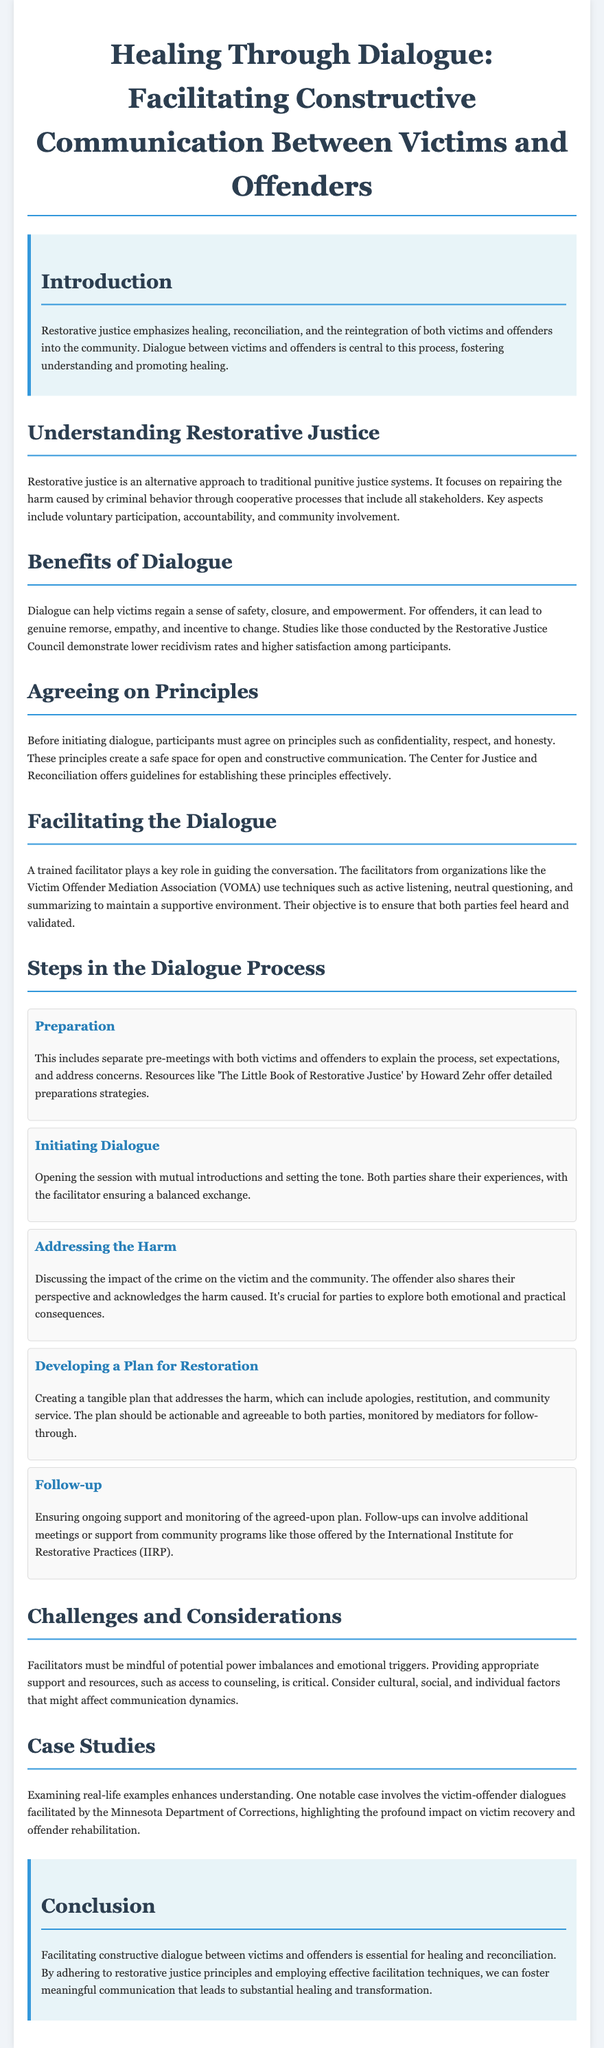What is the title of the lesson plan? The title is mentioned at the top of the document and defines the focus of the lesson plan.
Answer: Healing Through Dialogue: Facilitating Constructive Communication Between Victims and Offenders What is a key aspect of restorative justice mentioned in the document? The document outlines several key aspects of restorative justice in the section about understanding it.
Answer: Voluntary participation What role does the facilitator play in the dialogue? The document explains the responsibilities of a facilitator in a specific section, emphasizing their importance in guiding the conversation.
Answer: Guiding the conversation What is one benefit of dialogue for victims? The document lists various benefits of dialogue, specifically highlighting how it impacts victims.
Answer: Regain a sense of safety What is one principle that participants must agree on before dialogue? The document specifies several principles that are essential for establishing a safe dialogue environment.
Answer: Confidentiality What is one of the steps in the dialogue process? The text outlines a sequence of steps involved in the dialogue process, indicating a structured approach.
Answer: Preparation What does the document suggest about the follow-up process? The section on follow-up discusses the ongoing support needed after the initial dialogue.
Answer: Ongoing support What challenges might facilitators face during the dialogue? The document identifies challenges and considerations that facilitators must be aware of throughout the process.
Answer: Power imbalances Which organization is mentioned as offering mediation services? The document references specific organizations that provide mediation services to facilitate restorative justice dialogue.
Answer: Victim Offender Mediation Association (VOMA) 